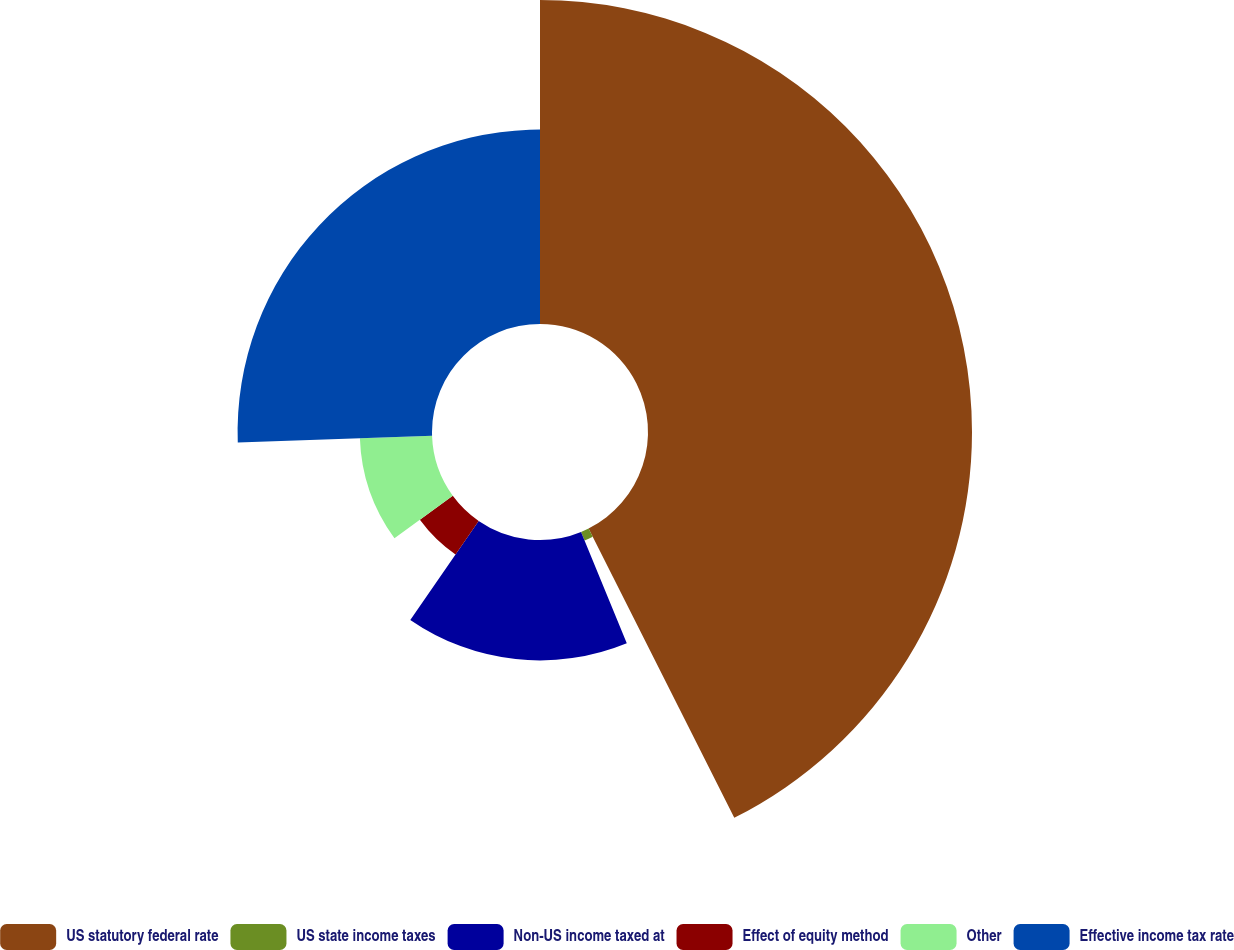Convert chart to OTSL. <chart><loc_0><loc_0><loc_500><loc_500><pie_chart><fcel>US statutory federal rate<fcel>US state income taxes<fcel>Non-US income taxed at<fcel>Effect of equity method<fcel>Other<fcel>Effective income tax rate<nl><fcel>42.58%<fcel>1.22%<fcel>15.82%<fcel>5.35%<fcel>9.49%<fcel>25.55%<nl></chart> 